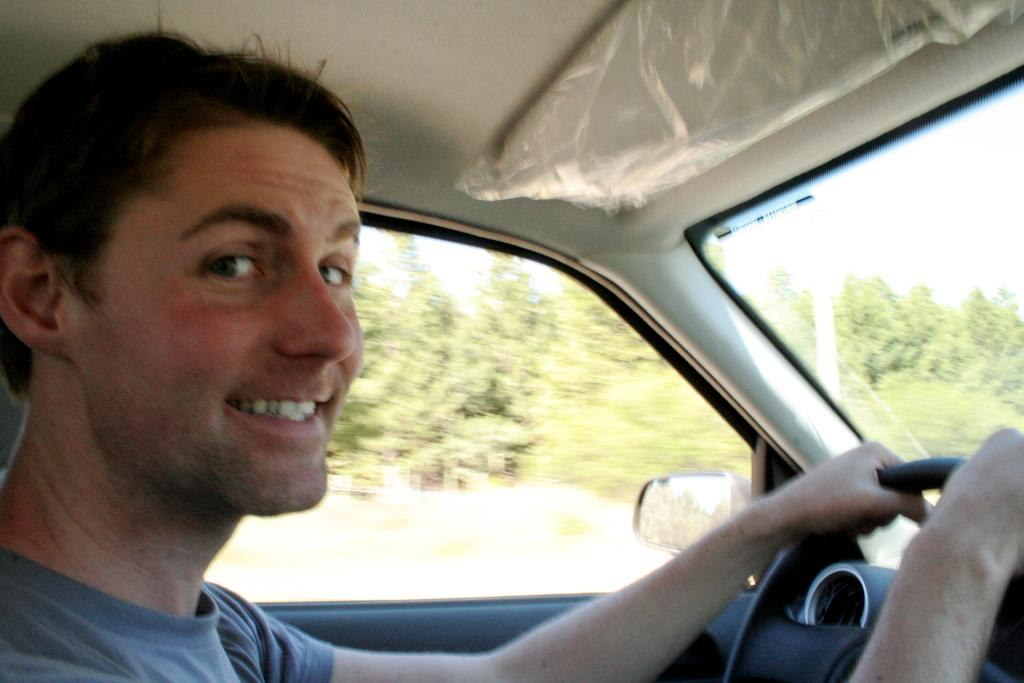What is the man in the image doing? The man is inside a vehicle in the image. Can you describe any specific features of the vehicle? There is a mirror visible in the image, which may be part of the vehicle's interior. What can be seen outside the vehicle in the image? Trees are visible in the image. What type of bubble can be seen floating near the trees in the image? There is no bubble present in the image; it only features a man inside a vehicle and trees in the background. 